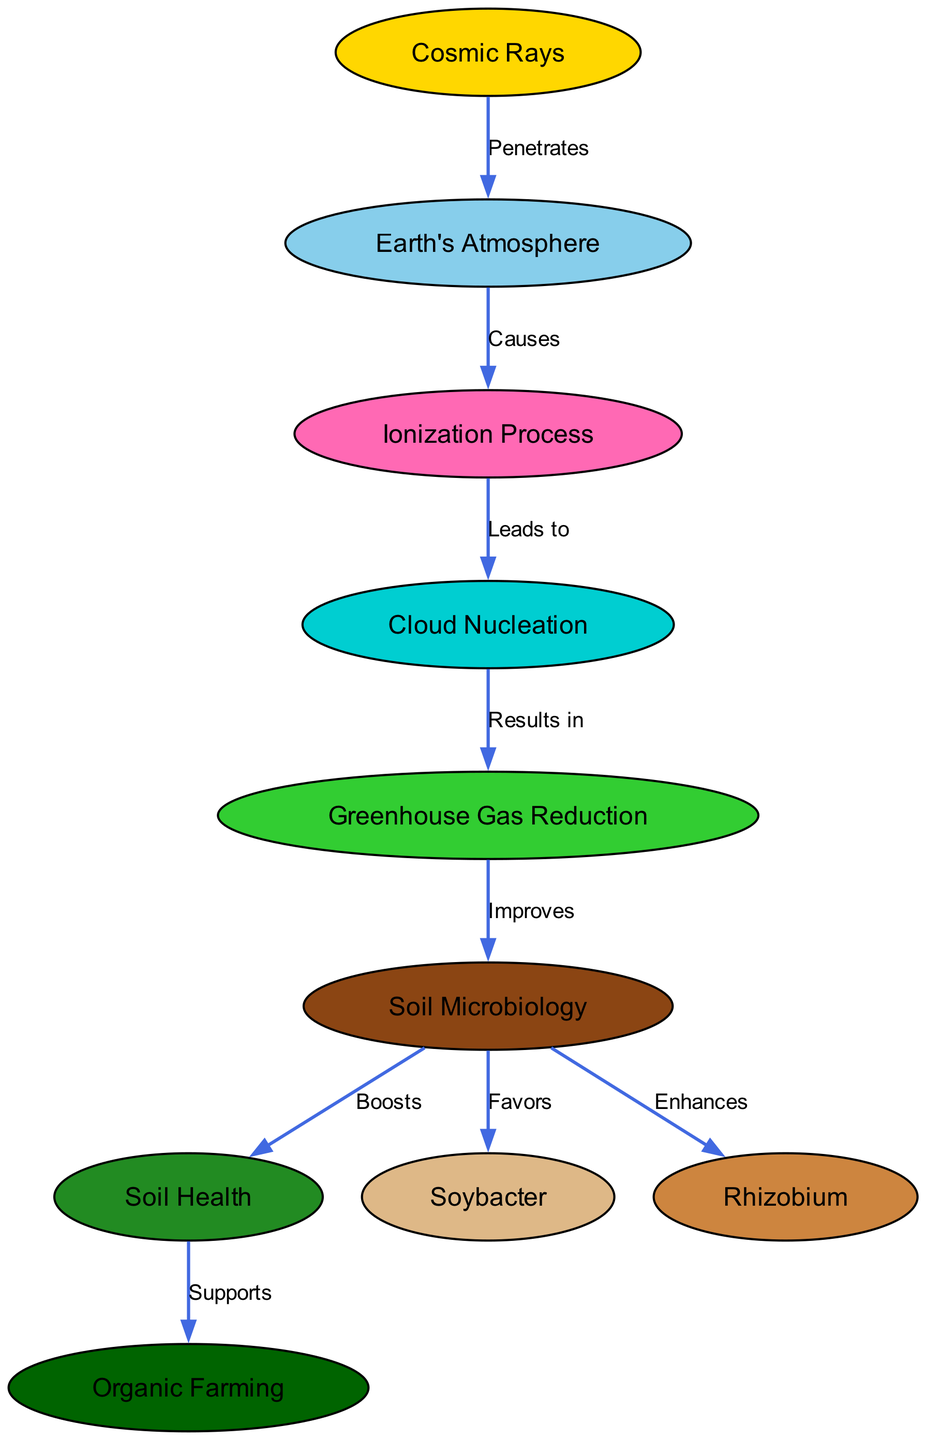What is the relationship between Cosmic Rays and Earth’s Atmosphere? The diagram indicates that Cosmic Rays "Penetrate" Earth's Atmosphere, demonstrating a direct influence of cosmic radiation on the atmospheric layer.
Answer: Penetrates How many nodes are present in the diagram? By counting the distinct nodes labeled in the diagram, we find there are 8 nodes representing various concepts involved, including Cosmic Rays, Earth's Atmosphere, Ionization Process, and others.
Answer: 8 What process follows Ionization according to the diagram? The diagram shows that Ionization "Leads to" Cloud Nucleation, indicating this is the sequence in the atmospheric interactions facilitated by cosmic rays.
Answer: Leads to What does Cloud Nucleation result in? According to the diagram, the result of Cloud Nucleation is "Greenhouse Gas Reduction," connecting micro-level atmospheric changes to macro-level environmental outcomes.
Answer: Greenhouse Gas Reduction How does Greenhouse Gas Reduction impact Soil Microbiology? The diagram specifies that Greenhouse Gas Reduction "Improves" Soil Microbiology, suggesting a beneficial effect that helps enhance the microbial community in the soil due to reduced greenhouse gases.
Answer: Improves Which bacteria does Soil Microbiology favor, as indicated in the diagram? The diagram explicitly states that Soil Microbiology "Favors" Soybacter, showing a positive influence of healthy microbiological activity on specific beneficial bacteria.
Answer: Soybacter What type of farming is supported by Soil Health in the diagram? The relationship depicted indicates that Soil Health "Supports" Organic Farming, showing the direct connection between healthy soil and sustainable agricultural practices.
Answer: Organic Farming Explain the sequence of processes starting from Cosmic Rays to Soil Health. Starting with Cosmic Rays that penetrate the Earth's Atmosphere, this leads to the Ionization Process, which in turn causes Cloud Nucleation. The result of Cloud Nucleation is Greenhouse Gas Reduction, which subsequently improves Soil Microbiology. From improved Soil Microbiology, we see benefits for both Soybacter and Rhizobium, culminating in boosted Soil Health that supports Organic Farming.
Answer: Cosmic Rays -> Earth's Atmosphere -> Ionization -> Nucleation -> GHG Reduction -> Soil Microbiology -> Soil Health -> Organic Farming What enhances Rhizobium according to the diagram? The diagram states that Soil Microbiology "Enhances" Rhizobium, indicating the supportive role of the soil's microbial community on this essential bacteria for organic farming.
Answer: Enhances Rhizobium 